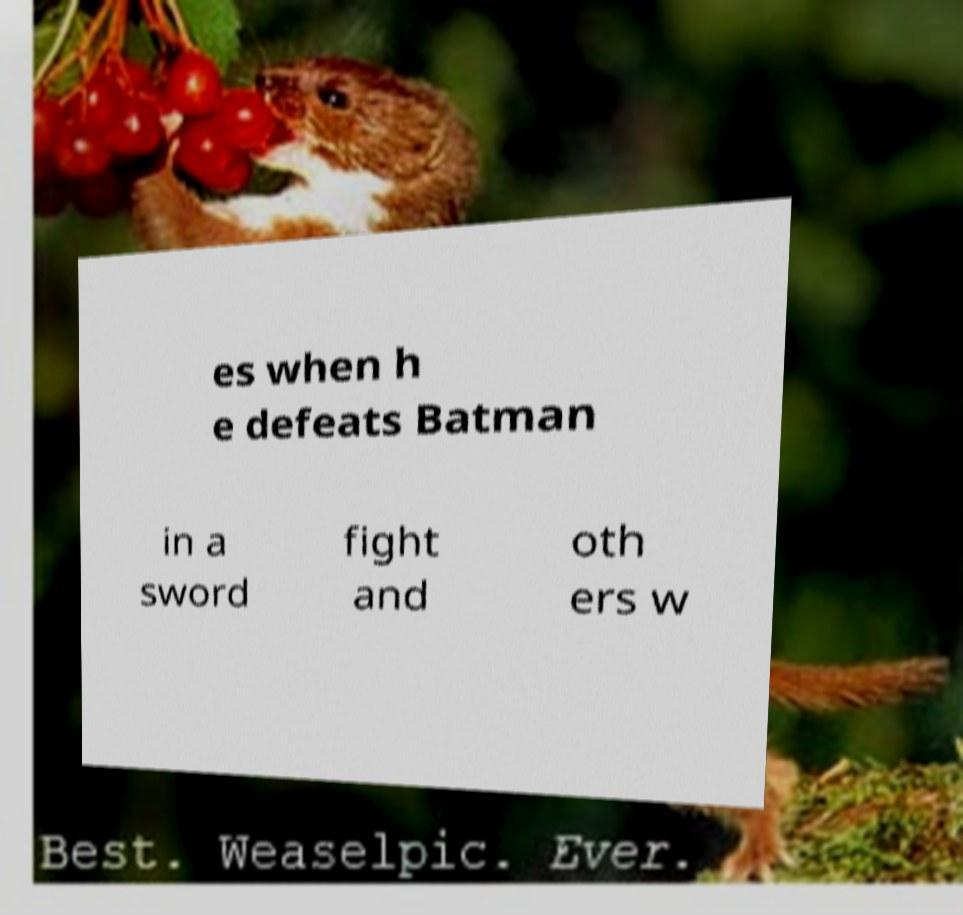Can you accurately transcribe the text from the provided image for me? es when h e defeats Batman in a sword fight and oth ers w 